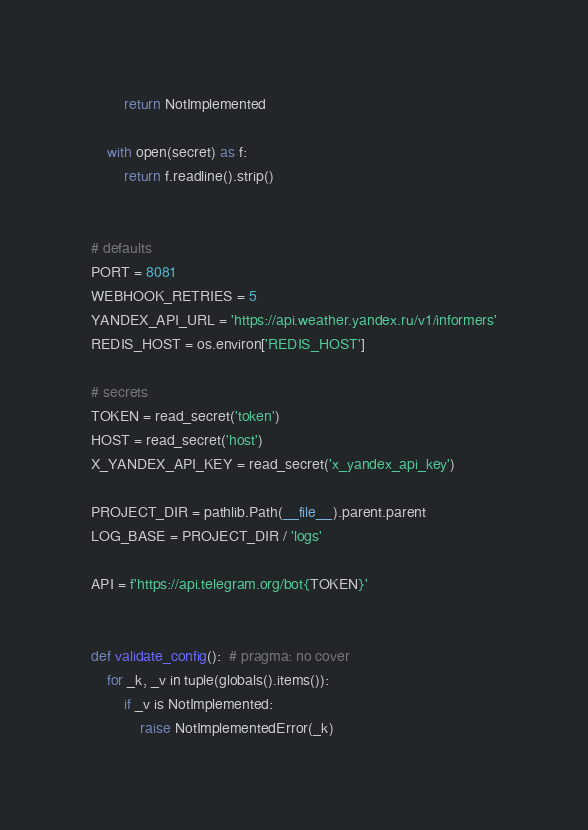<code> <loc_0><loc_0><loc_500><loc_500><_Python_>        return NotImplemented

    with open(secret) as f:
        return f.readline().strip()


# defaults
PORT = 8081
WEBHOOK_RETRIES = 5
YANDEX_API_URL = 'https://api.weather.yandex.ru/v1/informers'
REDIS_HOST = os.environ['REDIS_HOST']

# secrets
TOKEN = read_secret('token')
HOST = read_secret('host')
X_YANDEX_API_KEY = read_secret('x_yandex_api_key')

PROJECT_DIR = pathlib.Path(__file__).parent.parent
LOG_BASE = PROJECT_DIR / 'logs'

API = f'https://api.telegram.org/bot{TOKEN}'


def validate_config():  # pragma: no cover
    for _k, _v in tuple(globals().items()):
        if _v is NotImplemented:
            raise NotImplementedError(_k)
</code> 